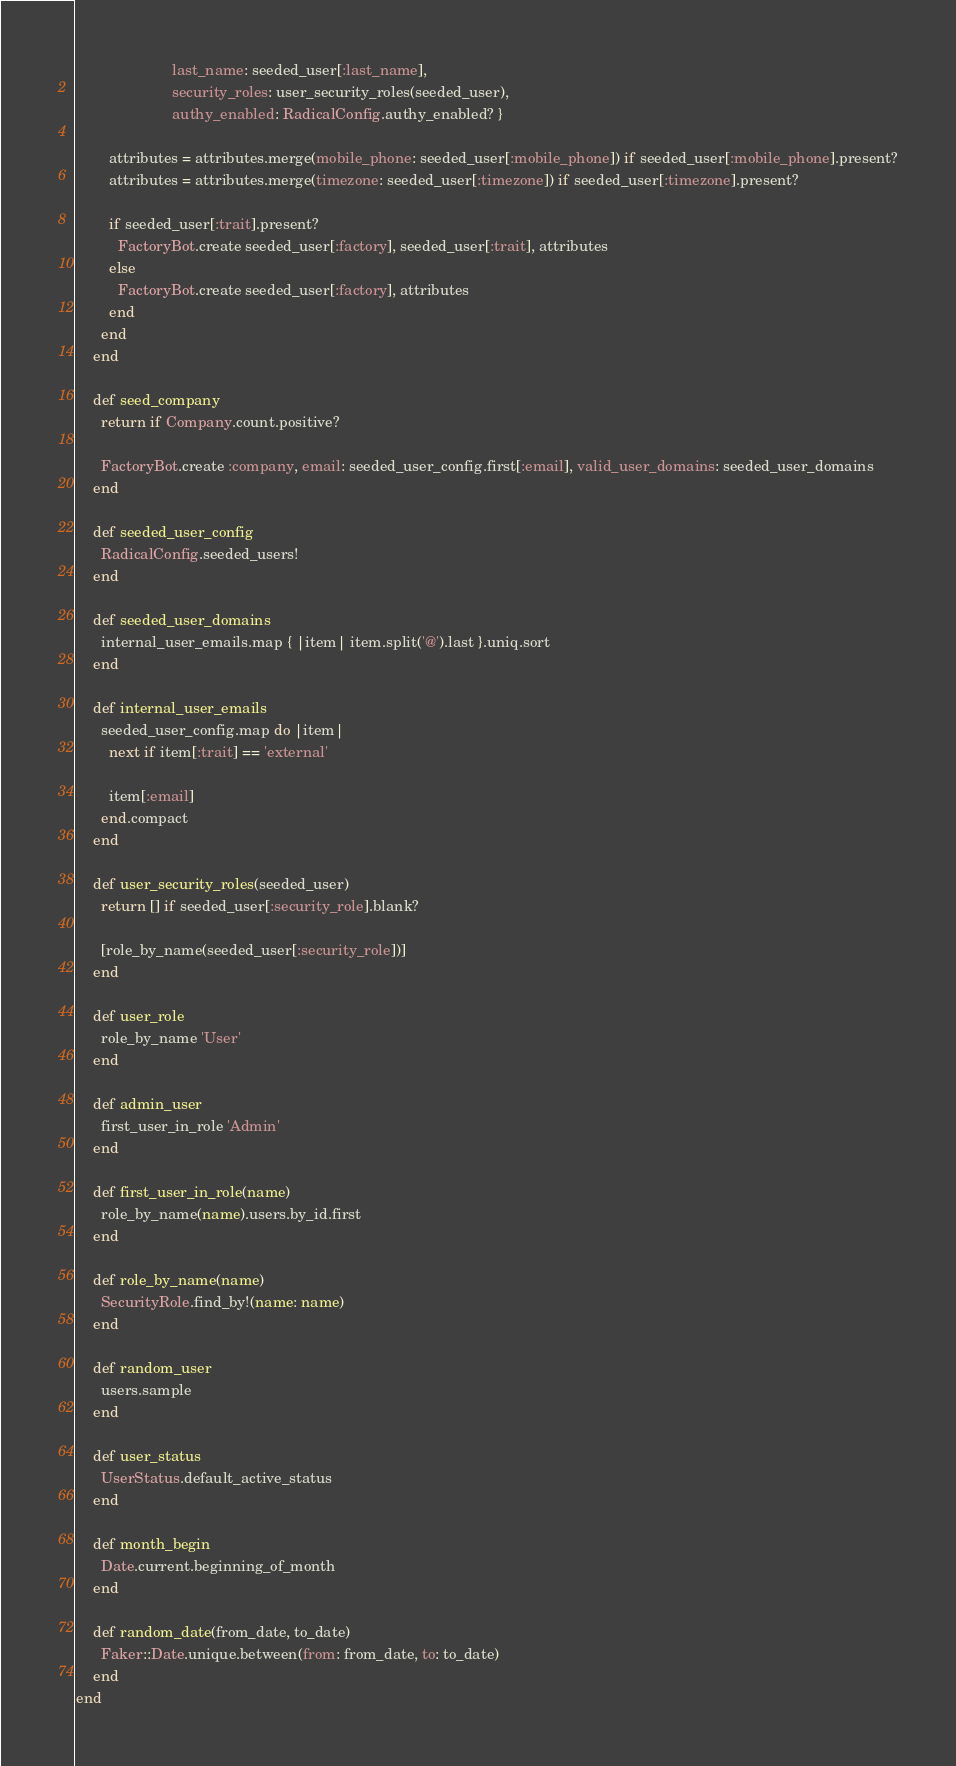<code> <loc_0><loc_0><loc_500><loc_500><_Ruby_>                       last_name: seeded_user[:last_name],
                       security_roles: user_security_roles(seeded_user),
                       authy_enabled: RadicalConfig.authy_enabled? }

        attributes = attributes.merge(mobile_phone: seeded_user[:mobile_phone]) if seeded_user[:mobile_phone].present?
        attributes = attributes.merge(timezone: seeded_user[:timezone]) if seeded_user[:timezone].present?

        if seeded_user[:trait].present?
          FactoryBot.create seeded_user[:factory], seeded_user[:trait], attributes
        else
          FactoryBot.create seeded_user[:factory], attributes
        end
      end
    end

    def seed_company
      return if Company.count.positive?

      FactoryBot.create :company, email: seeded_user_config.first[:email], valid_user_domains: seeded_user_domains
    end

    def seeded_user_config
      RadicalConfig.seeded_users!
    end

    def seeded_user_domains
      internal_user_emails.map { |item| item.split('@').last }.uniq.sort
    end

    def internal_user_emails
      seeded_user_config.map do |item|
        next if item[:trait] == 'external'

        item[:email]
      end.compact
    end

    def user_security_roles(seeded_user)
      return [] if seeded_user[:security_role].blank?

      [role_by_name(seeded_user[:security_role])]
    end

    def user_role
      role_by_name 'User'
    end

    def admin_user
      first_user_in_role 'Admin'
    end

    def first_user_in_role(name)
      role_by_name(name).users.by_id.first
    end

    def role_by_name(name)
      SecurityRole.find_by!(name: name)
    end

    def random_user
      users.sample
    end

    def user_status
      UserStatus.default_active_status
    end

    def month_begin
      Date.current.beginning_of_month
    end

    def random_date(from_date, to_date)
      Faker::Date.unique.between(from: from_date, to: to_date)
    end
end
</code> 